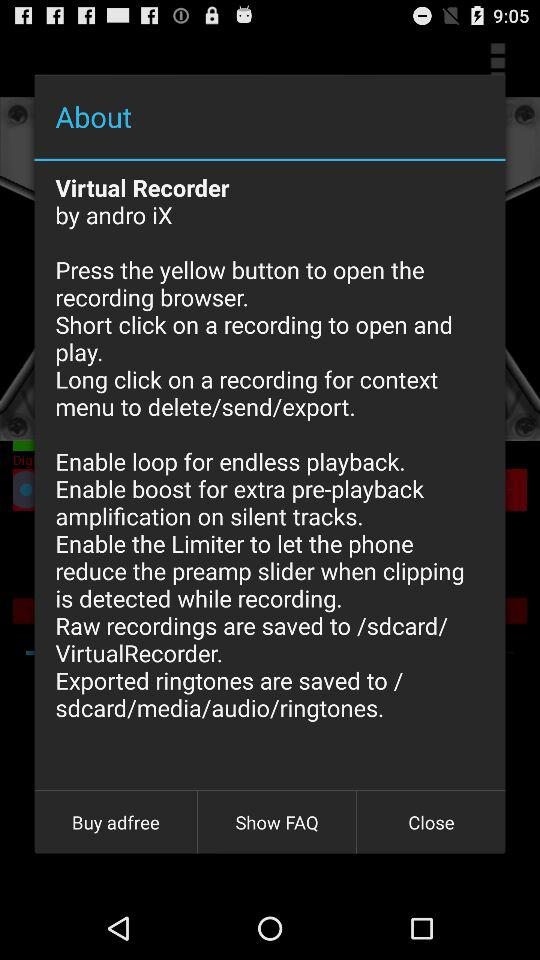What is a virtual recorder?
When the provided information is insufficient, respond with <no answer>. <no answer> 